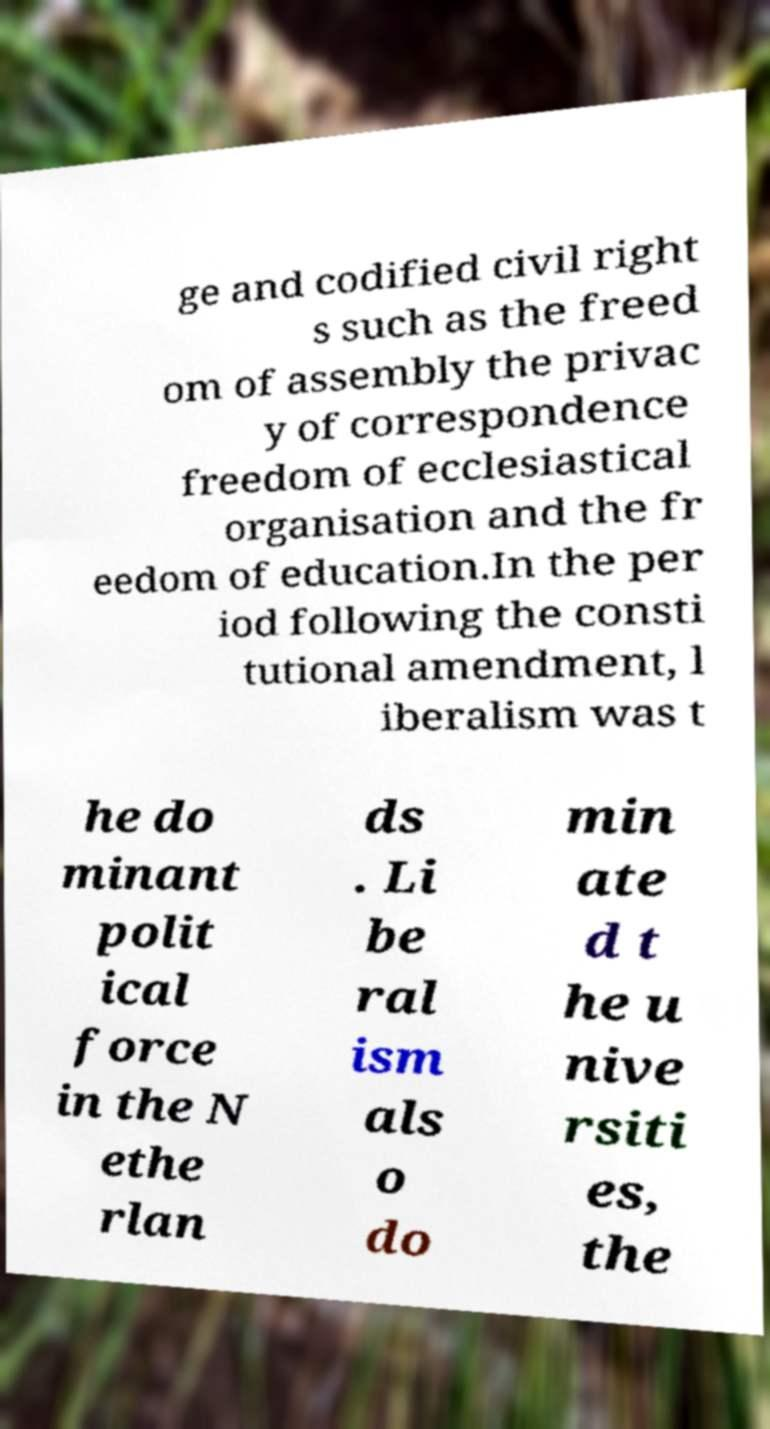For documentation purposes, I need the text within this image transcribed. Could you provide that? ge and codified civil right s such as the freed om of assembly the privac y of correspondence freedom of ecclesiastical organisation and the fr eedom of education.In the per iod following the consti tutional amendment, l iberalism was t he do minant polit ical force in the N ethe rlan ds . Li be ral ism als o do min ate d t he u nive rsiti es, the 